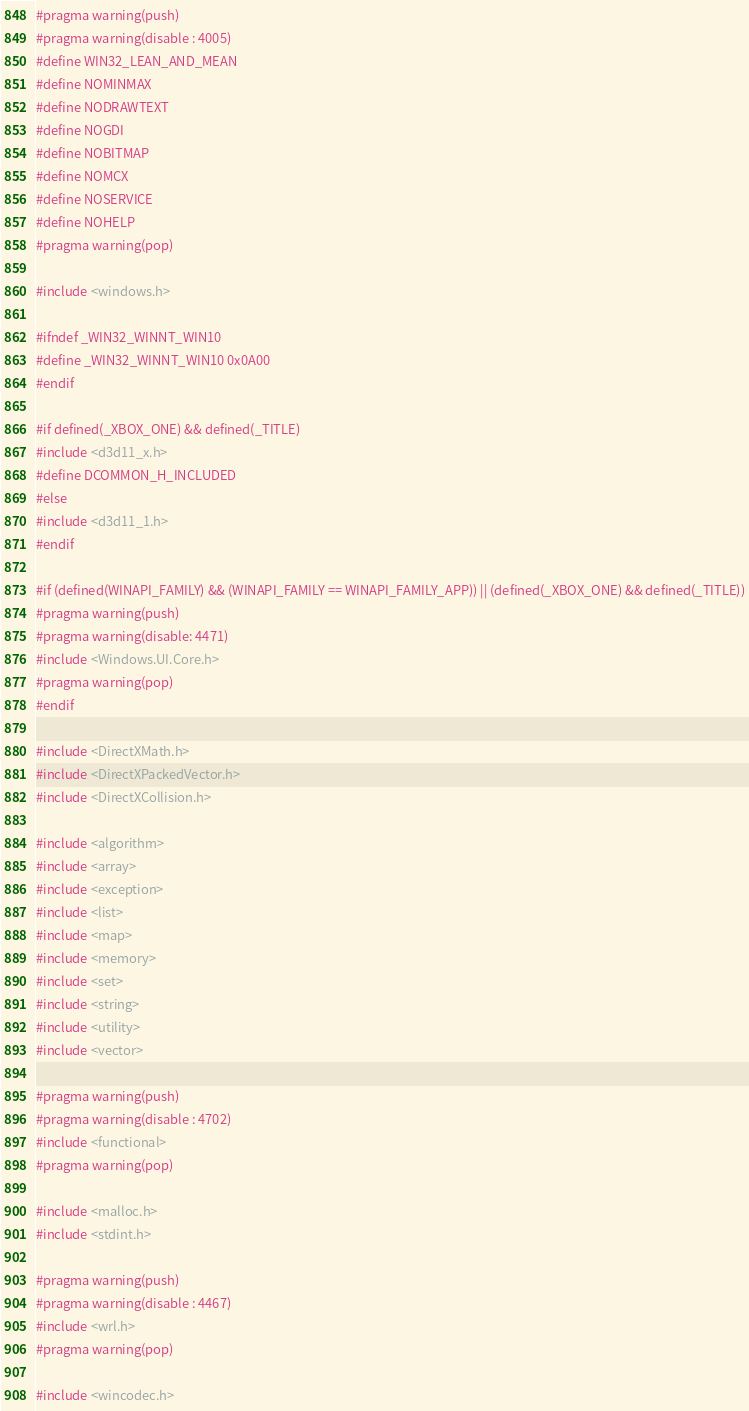Convert code to text. <code><loc_0><loc_0><loc_500><loc_500><_C_>#pragma warning(push)
#pragma warning(disable : 4005)
#define WIN32_LEAN_AND_MEAN
#define NOMINMAX
#define NODRAWTEXT
#define NOGDI
#define NOBITMAP
#define NOMCX
#define NOSERVICE
#define NOHELP
#pragma warning(pop)

#include <windows.h>

#ifndef _WIN32_WINNT_WIN10
#define _WIN32_WINNT_WIN10 0x0A00
#endif

#if defined(_XBOX_ONE) && defined(_TITLE)
#include <d3d11_x.h>
#define DCOMMON_H_INCLUDED
#else
#include <d3d11_1.h>
#endif

#if (defined(WINAPI_FAMILY) && (WINAPI_FAMILY == WINAPI_FAMILY_APP)) || (defined(_XBOX_ONE) && defined(_TITLE))
#pragma warning(push)
#pragma warning(disable: 4471)
#include <Windows.UI.Core.h>
#pragma warning(pop)
#endif

#include <DirectXMath.h>
#include <DirectXPackedVector.h>
#include <DirectXCollision.h>

#include <algorithm>
#include <array>
#include <exception>
#include <list>
#include <map>
#include <memory>
#include <set>
#include <string>
#include <utility>
#include <vector>

#pragma warning(push)
#pragma warning(disable : 4702)
#include <functional>
#pragma warning(pop)

#include <malloc.h>
#include <stdint.h>

#pragma warning(push)
#pragma warning(disable : 4467)
#include <wrl.h>
#pragma warning(pop)

#include <wincodec.h>
</code> 